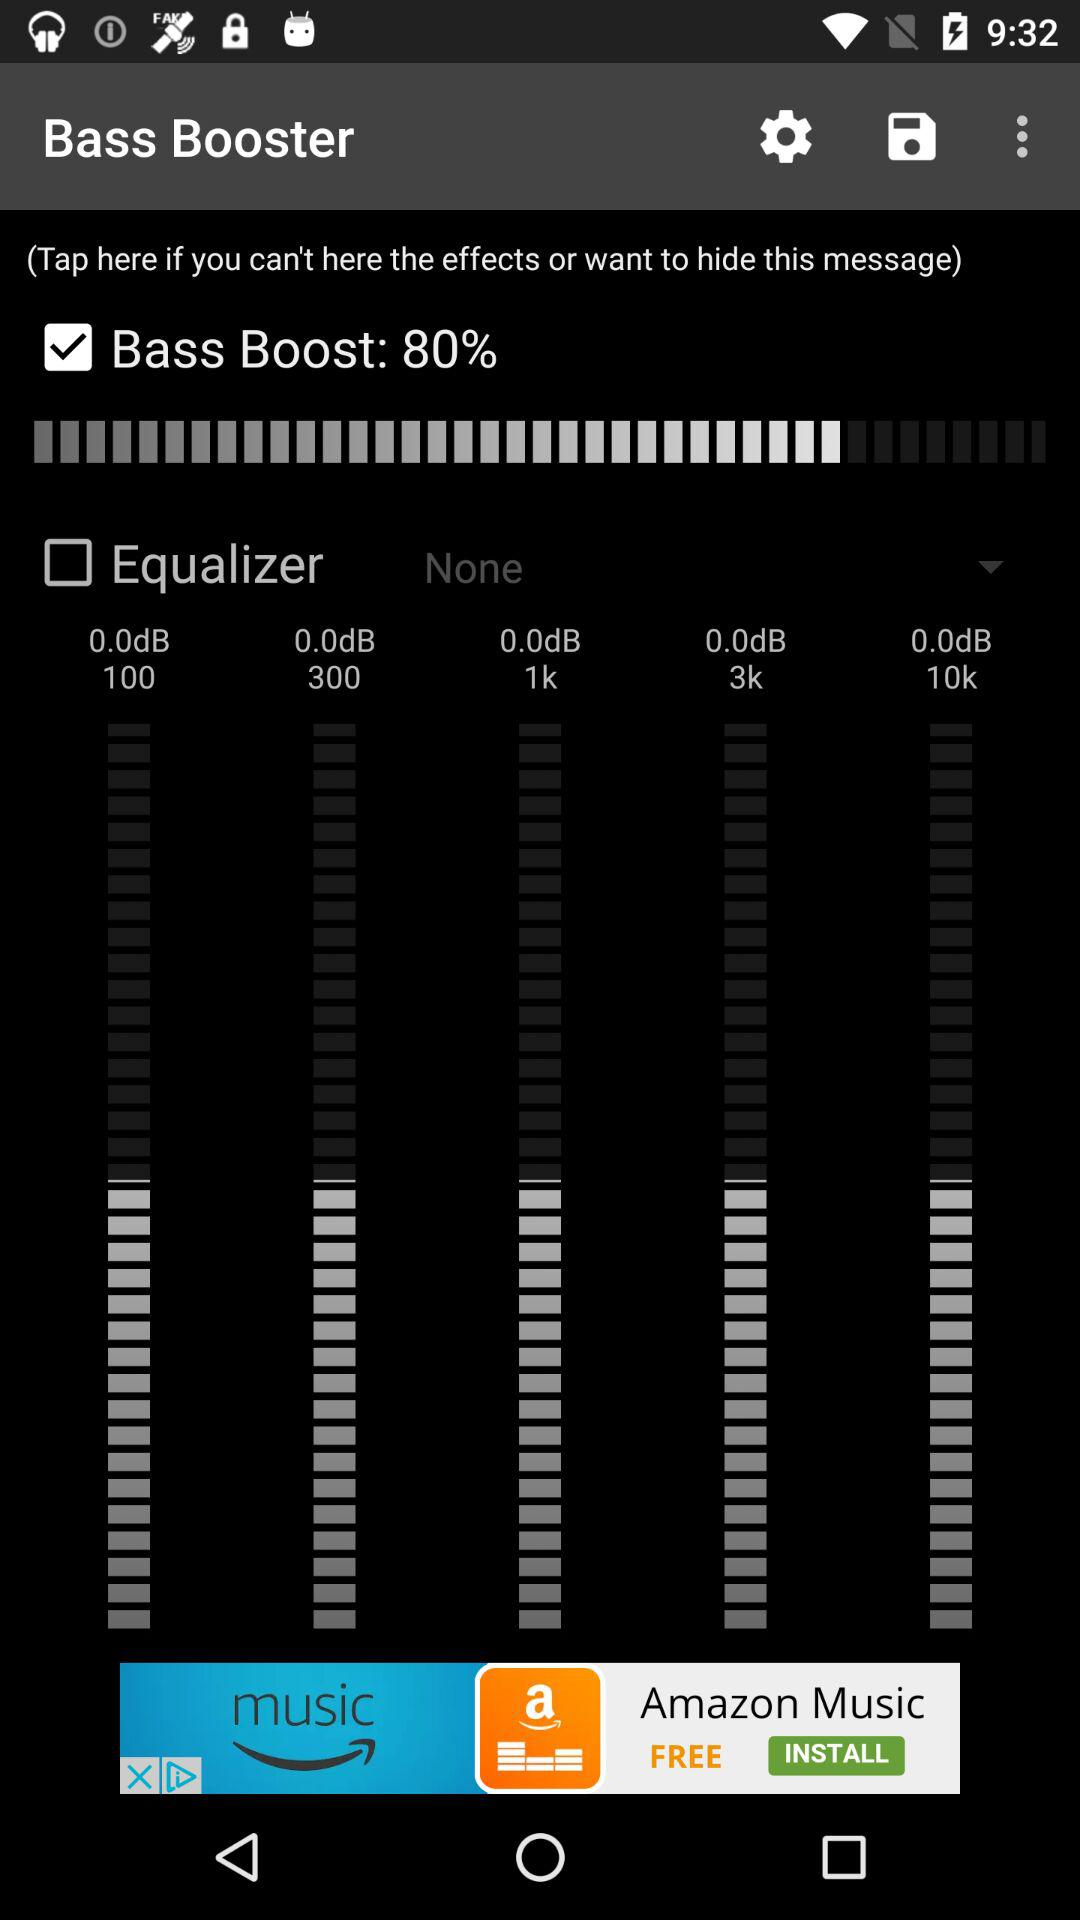What is the status of "Equalizer"? The status of "Equalizer" is "off". 